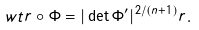<formula> <loc_0><loc_0><loc_500><loc_500>\ w t r \circ \Phi = | \det \Phi ^ { \prime } | ^ { 2 / ( n + 1 ) } r .</formula> 